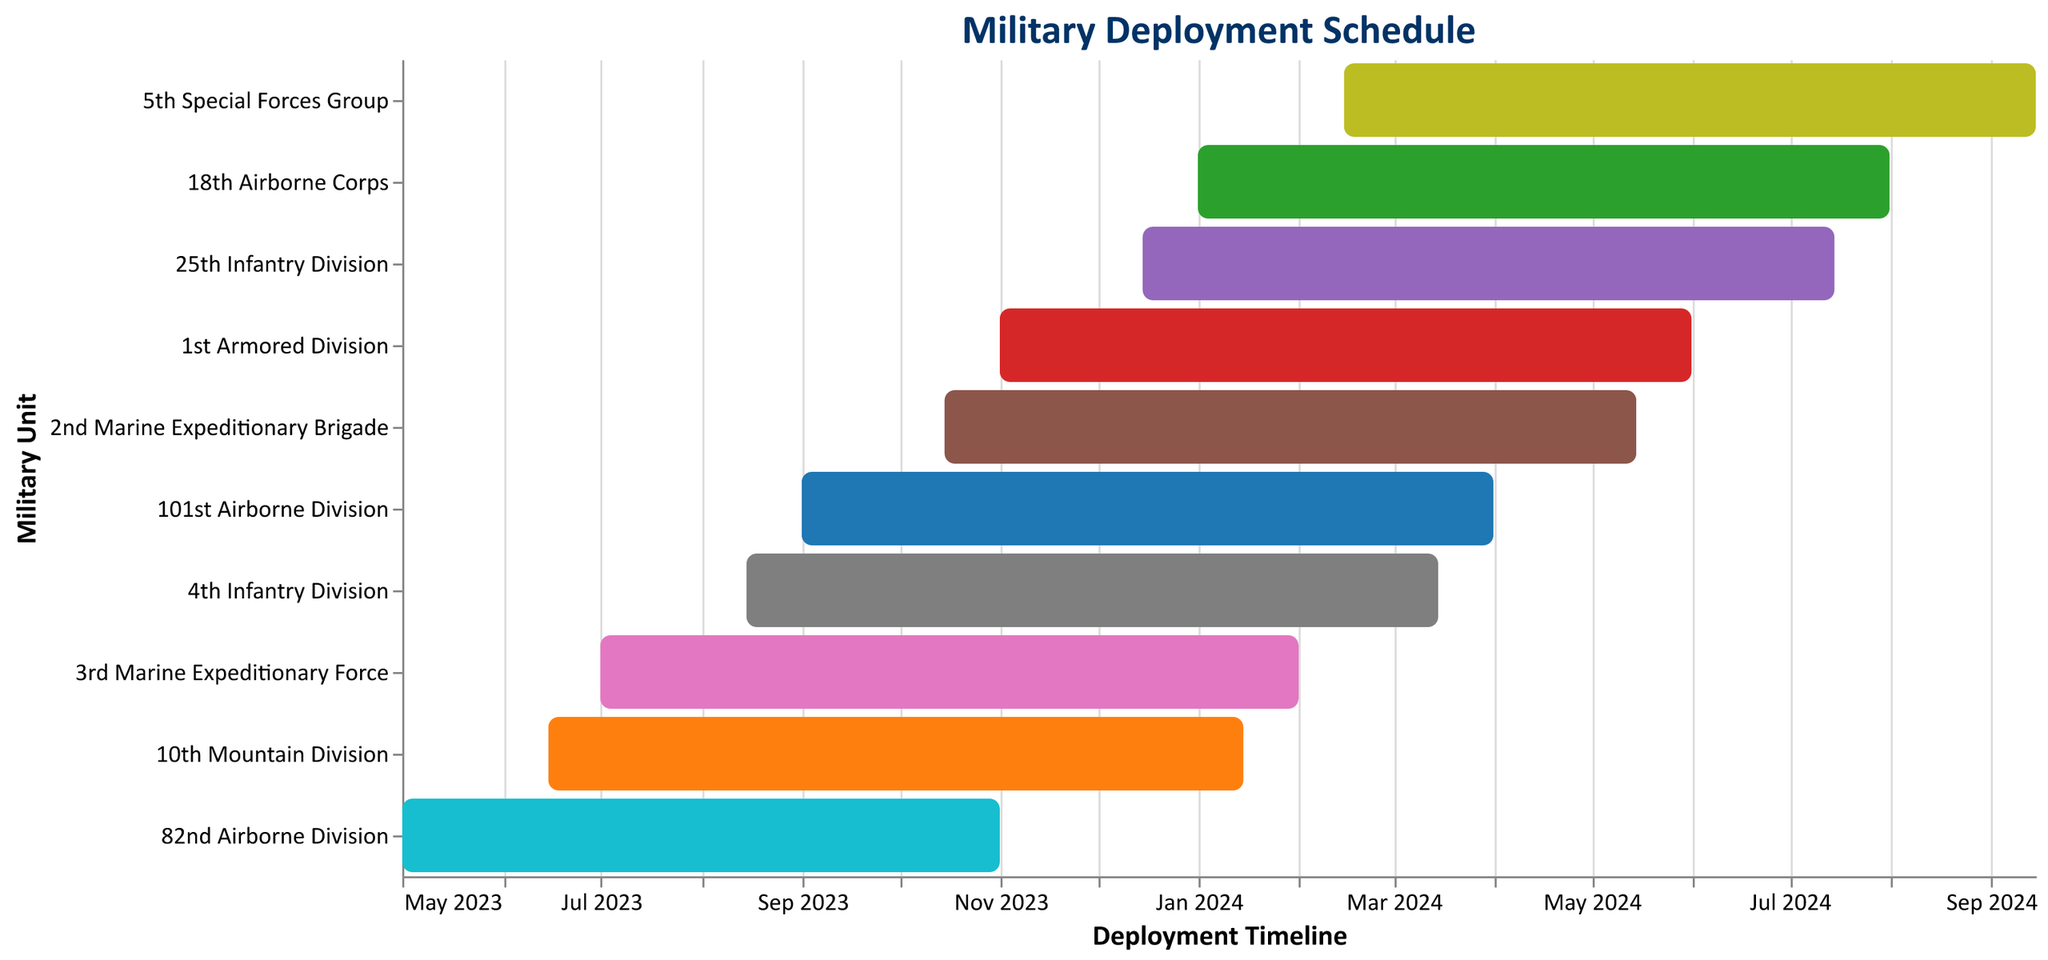Which military unit has the earliest deployment start date? By examining the "Start Date" axis, we see that the earliest date is "May 2023," corresponding to the "82nd Airborne Division."
Answer: 82nd Airborne Division Which unit has the latest deployment end date? The "End Date" axis shows the deployment completion, and the last bar ending in "September 2024" belongs to the "5th Special Forces Group."
Answer: 5th Special Forces Group What is the duration of the deployment for the "10th Mountain Division"? Calculate the difference between the "Start Date" (June 15, 2023) and "End Date" (January 15, 2024). The duration is 7 months.
Answer: 7 months Which units have deployments overlapping with the 82nd Airborne Division? The 82nd Airborne Division is deployed from May 2023 to November 2023. All units that start between these dates have overlapping deployments. These are "10th Mountain Division," "3rd Marine Expeditionary Force," "4th Infantry Division," "101st Airborne Division," and "2nd Marine Expeditionary Brigade."
Answer: 10th Mountain Division, 3rd Marine Expeditionary Force, 4th Infantry Division, 101st Airborne Division, 2nd Marine Expeditionary Brigade How many units are deployed in January 2024? By looking at the timeline, the units deployed in January 2024 are "10th Mountain Division," "3rd Marine Expeditionary Force," "4th Infantry Division," "101st Airborne Division," "2nd Marine Expeditionary Brigade," and the "1st Armored Division," so there are six.
Answer: 6 Which unit has the longest deployment duration? Compare the lengths of all the bars. The "5th Special Forces Group" has the longest bar from February 2024 to September 2024, making it about 7 months.
Answer: 5th Special Forces Group How does the deployment duration of the "82nd Airborne Division" compare to the "1st Armored Division"? The "82nd Airborne Division" has a duration from May 2023 to November 2023 (6 months), and the "1st Armored Division" from November 2023 to June 2024 (7 months). The "1st Armored Division" has a longer deployment.
Answer: "1st Armored Division" has a longer deployment What month and year does the "101st Airborne Division" deployment end? The "101st Airborne Division" ends its deployment in April 2024.
Answer: April 2024 Which units have deployment durations of exactly seven months? Identify units with bars spanning 7 months: "10th Mountain Division," "2nd Marine Expeditionary Brigade," and "5th Special Forces Group" all have 7-month deployments.
Answer: 10th Mountain Division, 2nd Marine Expeditionary Brigade, 5th Special Forces Group 